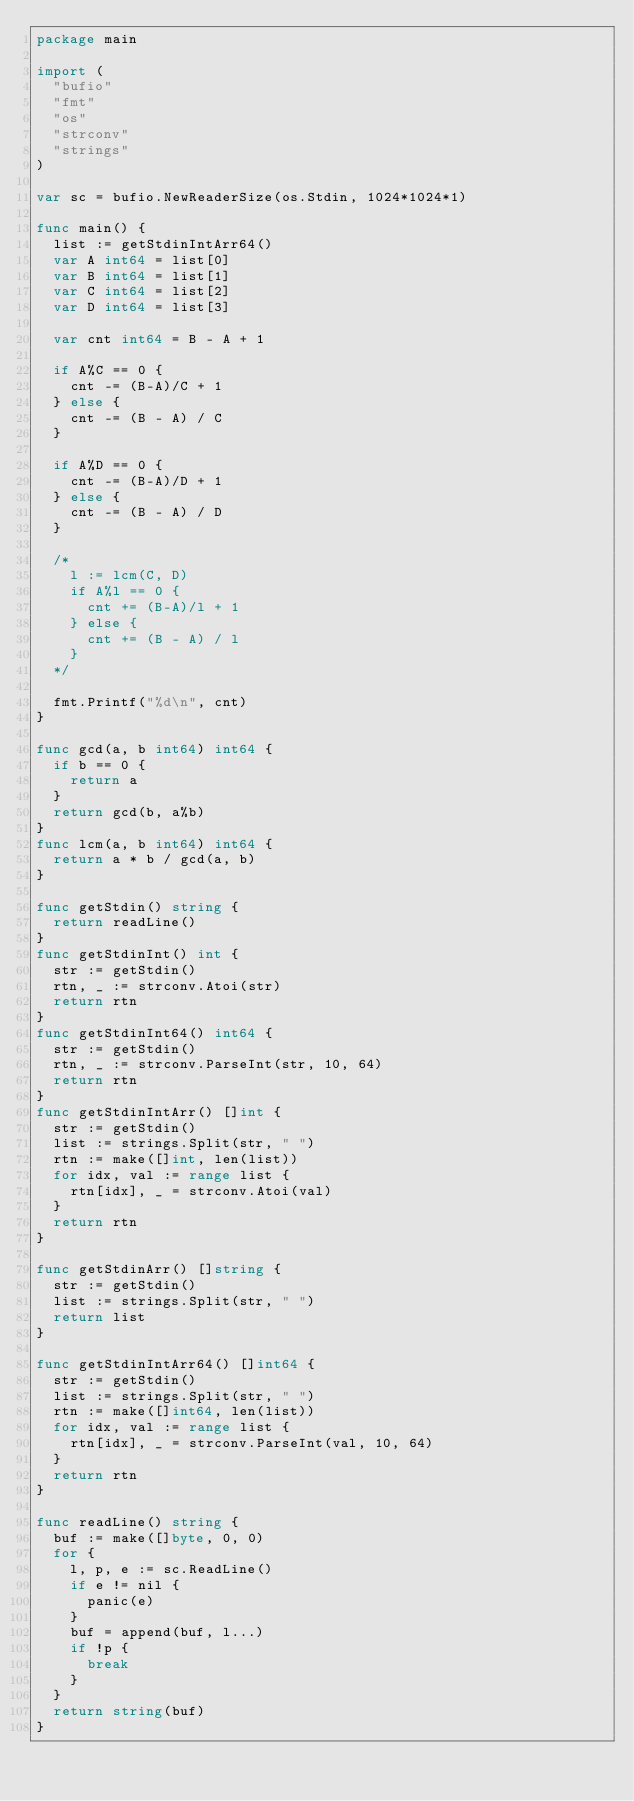Convert code to text. <code><loc_0><loc_0><loc_500><loc_500><_Go_>package main

import (
	"bufio"
	"fmt"
	"os"
	"strconv"
	"strings"
)

var sc = bufio.NewReaderSize(os.Stdin, 1024*1024*1)

func main() {
	list := getStdinIntArr64()
	var A int64 = list[0]
	var B int64 = list[1]
	var C int64 = list[2]
	var D int64 = list[3]

	var cnt int64 = B - A + 1

	if A%C == 0 {
		cnt -= (B-A)/C + 1
	} else {
		cnt -= (B - A) / C
	}

	if A%D == 0 {
		cnt -= (B-A)/D + 1
	} else {
		cnt -= (B - A) / D
	}

	/*
		l := lcm(C, D)
		if A%l == 0 {
			cnt += (B-A)/l + 1
		} else {
			cnt += (B - A) / l
		}
	*/

	fmt.Printf("%d\n", cnt)
}

func gcd(a, b int64) int64 {
	if b == 0 {
		return a
	}
	return gcd(b, a%b)
}
func lcm(a, b int64) int64 {
	return a * b / gcd(a, b)
}

func getStdin() string {
	return readLine()
}
func getStdinInt() int {
	str := getStdin()
	rtn, _ := strconv.Atoi(str)
	return rtn
}
func getStdinInt64() int64 {
	str := getStdin()
	rtn, _ := strconv.ParseInt(str, 10, 64)
	return rtn
}
func getStdinIntArr() []int {
	str := getStdin()
	list := strings.Split(str, " ")
	rtn := make([]int, len(list))
	for idx, val := range list {
		rtn[idx], _ = strconv.Atoi(val)
	}
	return rtn
}

func getStdinArr() []string {
	str := getStdin()
	list := strings.Split(str, " ")
	return list
}

func getStdinIntArr64() []int64 {
	str := getStdin()
	list := strings.Split(str, " ")
	rtn := make([]int64, len(list))
	for idx, val := range list {
		rtn[idx], _ = strconv.ParseInt(val, 10, 64)
	}
	return rtn
}

func readLine() string {
	buf := make([]byte, 0, 0)
	for {
		l, p, e := sc.ReadLine()
		if e != nil {
			panic(e)
		}
		buf = append(buf, l...)
		if !p {
			break
		}
	}
	return string(buf)
}
</code> 